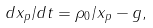<formula> <loc_0><loc_0><loc_500><loc_500>d x _ { p } / d t = \rho _ { 0 } / x _ { p } - g ,</formula> 